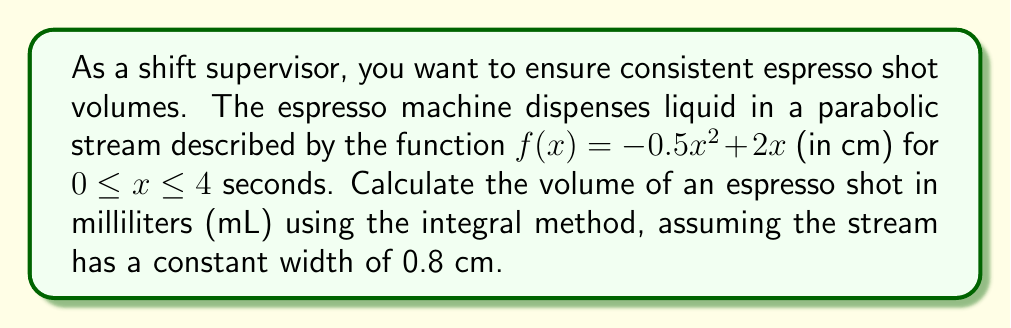Give your solution to this math problem. To calculate the volume of the espresso shot, we need to use the method of integration:

1) The volume can be found by rotating the area under the curve around the x-axis:
   $$V = \pi \int_0^4 [f(x)]^2 dx$$

2) However, we need to account for the constant width of 0.8 cm. This means we're not dealing with a full rotation, but a partial one. We can adjust our formula:
   $$V = 0.8 \int_0^4 f(x) dx$$

3) Substitute the function:
   $$V = 0.8 \int_0^4 (-0.5x^2 + 2x) dx$$

4) Integrate:
   $$V = 0.8 \left[-\frac{1}{6}x^3 + x^2\right]_0^4$$

5) Evaluate the integral:
   $$V = 0.8 \left[\left(-\frac{1}{6}(4^3) + 4^2\right) - \left(-\frac{1}{6}(0^3) + 0^2\right)\right]$$
   $$V = 0.8 \left[-\frac{64}{6} + 16\right] = 0.8 (5.33333...)$$

6) Simplify:
   $$V = 4.26666... \text{ cm}^3$$

7) Convert to mL (1 cm³ = 1 mL):
   $$V = 4.26666... \text{ mL}$$
Answer: $4.27 \text{ mL}$ 